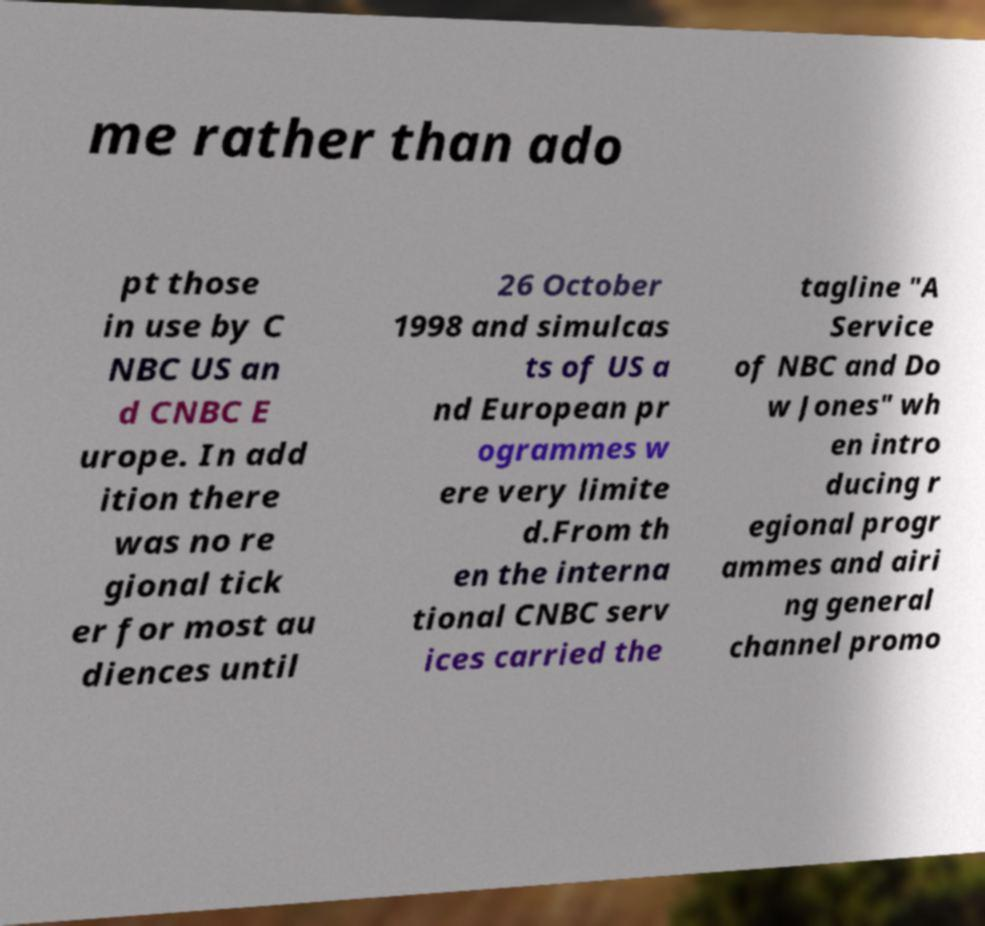Can you accurately transcribe the text from the provided image for me? me rather than ado pt those in use by C NBC US an d CNBC E urope. In add ition there was no re gional tick er for most au diences until 26 October 1998 and simulcas ts of US a nd European pr ogrammes w ere very limite d.From th en the interna tional CNBC serv ices carried the tagline "A Service of NBC and Do w Jones" wh en intro ducing r egional progr ammes and airi ng general channel promo 